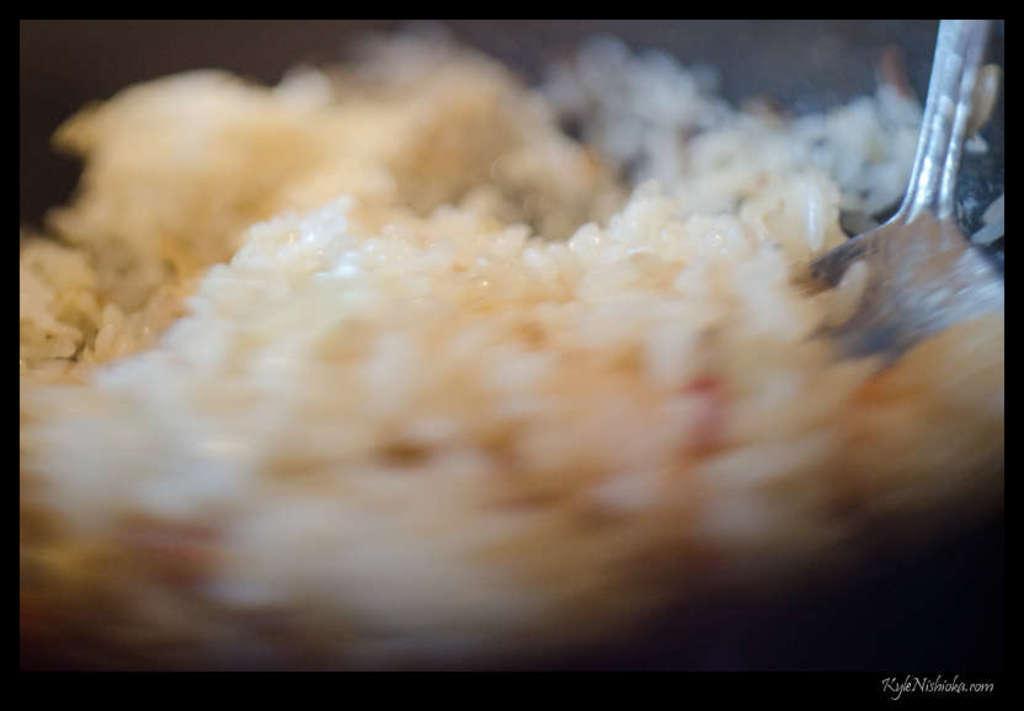Please provide a concise description of this image. In this picture we can see some food and a spoon. 